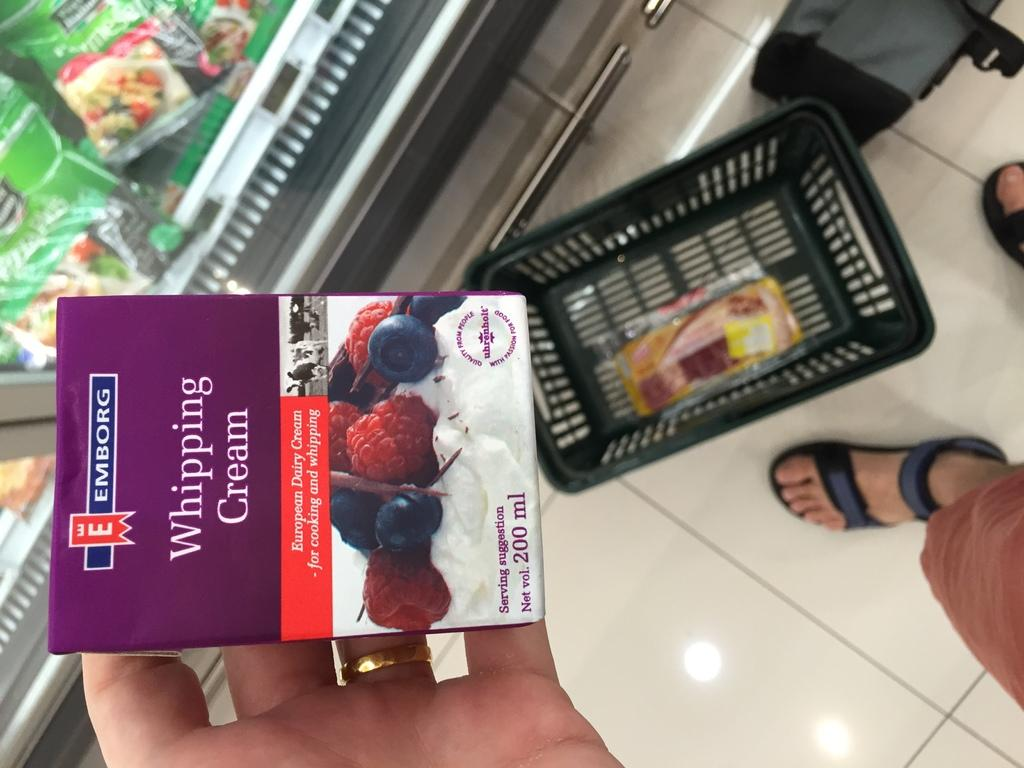<image>
Write a terse but informative summary of the picture. A person holding a box that reads Whipping Cream. 